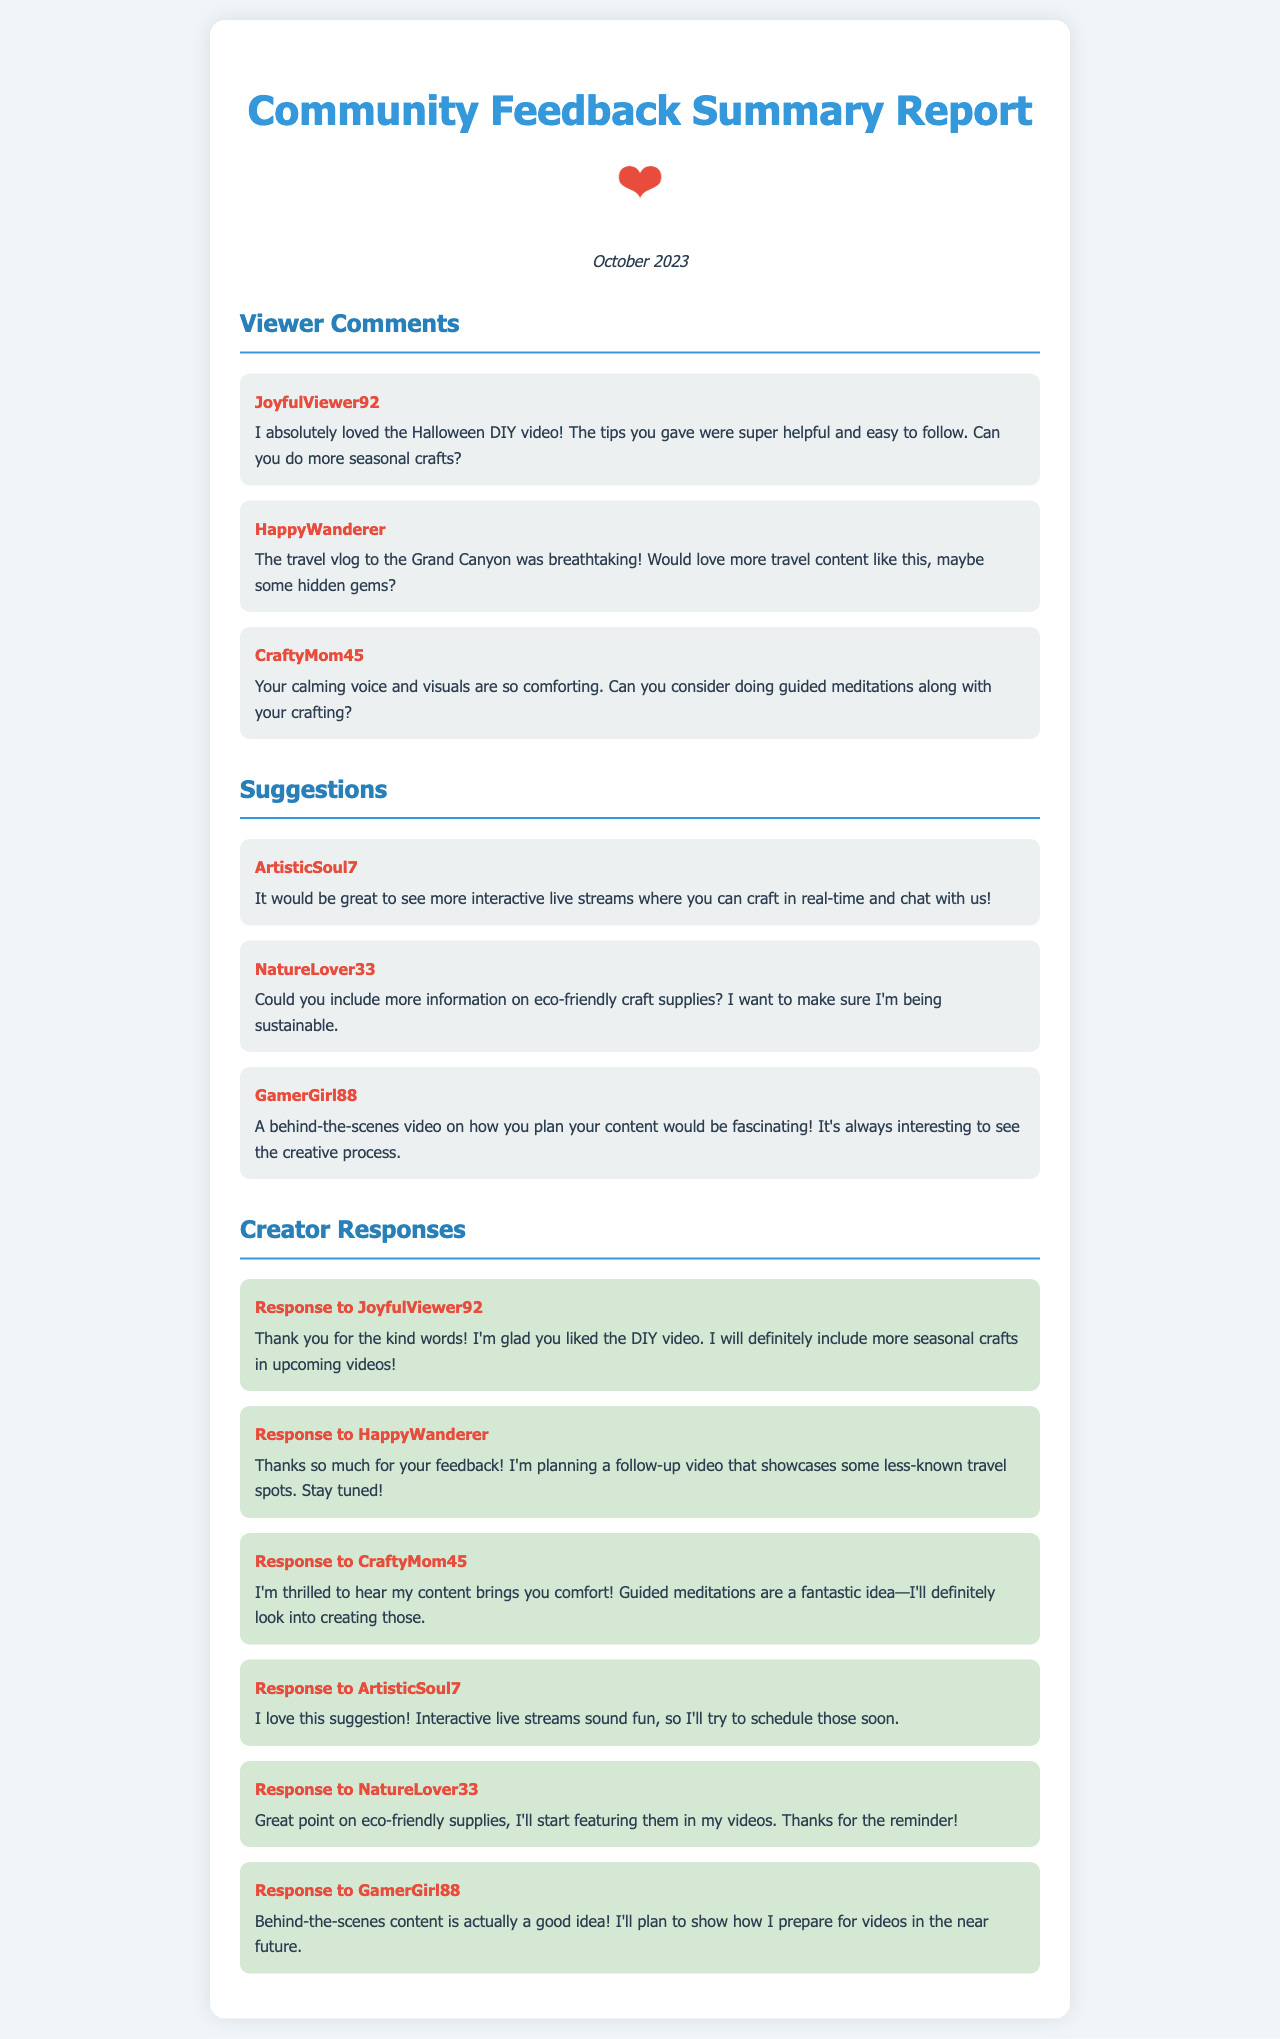What is the title of the report? The title of the report is stated at the top of the document.
Answer: Community Feedback Summary Report - October 2023 Who is the user that commented about seasonal crafts? The username is provided above the comment, identifying the user.
Answer: JoyfulViewer92 How many viewer comments are listed in the report? The count of comments can be found in the Viewer Comments section of the document.
Answer: 3 What is one suggestion made by ArtisticSoul7? The specific suggestion is highlighted in the Suggestions section attributed to the user.
Answer: More interactive live streams What response did the creator give to CraftyMom45? The creator's specific response is outlined in the Creator Responses section.
Answer: Guided meditations are a fantastic idea—I'll definitely look into creating those What type of content is HappyWanderer interested in? The comment identifies the type of content the user wishes to see more of in their interactions.
Answer: More travel content What is the mood of the feedback from the viewers? The overall tone of the feedback can be deduced from the positivity expressed in the comments.
Answer: Positive How many suggestions were made in total? The total number of suggestions can be found in the Suggestions section.
Answer: 3 What is a topic planned for upcoming videos according to the creator? The creator mentions future content based on user suggestions in their responses.
Answer: Less-known travel spots 